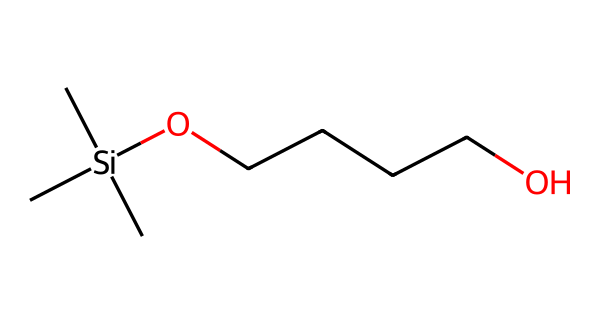what is the total number of carbon atoms in this compound? The SMILES representation shows the following sections: C[Si](C)(C) indicates three carbon atoms bonded to silicon, and OCCCCO shows four additional carbons in the chain. Adding these gives us a total of seven carbon atoms.
Answer: seven how many oxygen atoms are present in the structure? In the SMILES notation, the "O" appears twice, indicating there are two oxygen atoms in the compound.
Answer: two what is the functional group indicated by the presence of silicon and oxygen in this compound? The presence of silicon (Si) and oxygen (O) in this structure indicates it is an organosilicon compound, which generally features a siloxane or a similar functional group involving Si-O bonds.
Answer: organosilicon which part of this chemical can improve the coating properties in sports nutrition supplements? The long alkyl chain (OCCCCO), especially with the ether (indicated by the O between the carbon chain), is likely responsible for improving hydrophobic properties and adhesion in coatings.
Answer: long alkyl chain how does the silicon in this compound contribute to its stability? Silicon can provide increased thermal and chemical stability compared to carbon-based compounds. Its larger atomic size and unique bonding properties contribute to these stability aspects.
Answer: increased stability what type of bond connects silicon to carbon in this chemical? The bond that connects silicon to carbon is a covalent bond, as both elements share electrons in a manner typical for a stable organosilicon compound.
Answer: covalent bond 